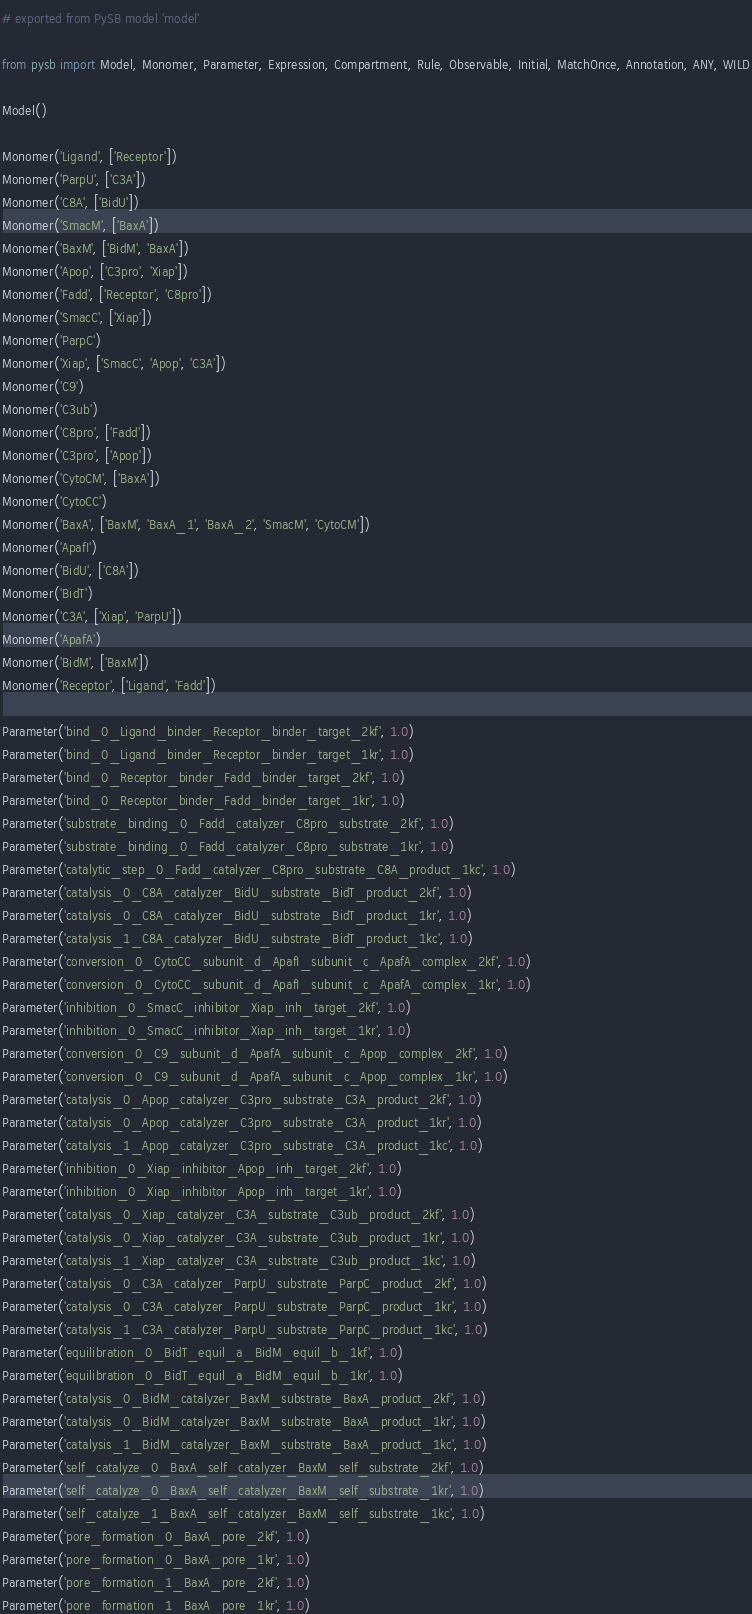Convert code to text. <code><loc_0><loc_0><loc_500><loc_500><_Python_># exported from PySB model 'model'

from pysb import Model, Monomer, Parameter, Expression, Compartment, Rule, Observable, Initial, MatchOnce, Annotation, ANY, WILD

Model()

Monomer('Ligand', ['Receptor'])
Monomer('ParpU', ['C3A'])
Monomer('C8A', ['BidU'])
Monomer('SmacM', ['BaxA'])
Monomer('BaxM', ['BidM', 'BaxA'])
Monomer('Apop', ['C3pro', 'Xiap'])
Monomer('Fadd', ['Receptor', 'C8pro'])
Monomer('SmacC', ['Xiap'])
Monomer('ParpC')
Monomer('Xiap', ['SmacC', 'Apop', 'C3A'])
Monomer('C9')
Monomer('C3ub')
Monomer('C8pro', ['Fadd'])
Monomer('C3pro', ['Apop'])
Monomer('CytoCM', ['BaxA'])
Monomer('CytoCC')
Monomer('BaxA', ['BaxM', 'BaxA_1', 'BaxA_2', 'SmacM', 'CytoCM'])
Monomer('ApafI')
Monomer('BidU', ['C8A'])
Monomer('BidT')
Monomer('C3A', ['Xiap', 'ParpU'])
Monomer('ApafA')
Monomer('BidM', ['BaxM'])
Monomer('Receptor', ['Ligand', 'Fadd'])

Parameter('bind_0_Ligand_binder_Receptor_binder_target_2kf', 1.0)
Parameter('bind_0_Ligand_binder_Receptor_binder_target_1kr', 1.0)
Parameter('bind_0_Receptor_binder_Fadd_binder_target_2kf', 1.0)
Parameter('bind_0_Receptor_binder_Fadd_binder_target_1kr', 1.0)
Parameter('substrate_binding_0_Fadd_catalyzer_C8pro_substrate_2kf', 1.0)
Parameter('substrate_binding_0_Fadd_catalyzer_C8pro_substrate_1kr', 1.0)
Parameter('catalytic_step_0_Fadd_catalyzer_C8pro_substrate_C8A_product_1kc', 1.0)
Parameter('catalysis_0_C8A_catalyzer_BidU_substrate_BidT_product_2kf', 1.0)
Parameter('catalysis_0_C8A_catalyzer_BidU_substrate_BidT_product_1kr', 1.0)
Parameter('catalysis_1_C8A_catalyzer_BidU_substrate_BidT_product_1kc', 1.0)
Parameter('conversion_0_CytoCC_subunit_d_ApafI_subunit_c_ApafA_complex_2kf', 1.0)
Parameter('conversion_0_CytoCC_subunit_d_ApafI_subunit_c_ApafA_complex_1kr', 1.0)
Parameter('inhibition_0_SmacC_inhibitor_Xiap_inh_target_2kf', 1.0)
Parameter('inhibition_0_SmacC_inhibitor_Xiap_inh_target_1kr', 1.0)
Parameter('conversion_0_C9_subunit_d_ApafA_subunit_c_Apop_complex_2kf', 1.0)
Parameter('conversion_0_C9_subunit_d_ApafA_subunit_c_Apop_complex_1kr', 1.0)
Parameter('catalysis_0_Apop_catalyzer_C3pro_substrate_C3A_product_2kf', 1.0)
Parameter('catalysis_0_Apop_catalyzer_C3pro_substrate_C3A_product_1kr', 1.0)
Parameter('catalysis_1_Apop_catalyzer_C3pro_substrate_C3A_product_1kc', 1.0)
Parameter('inhibition_0_Xiap_inhibitor_Apop_inh_target_2kf', 1.0)
Parameter('inhibition_0_Xiap_inhibitor_Apop_inh_target_1kr', 1.0)
Parameter('catalysis_0_Xiap_catalyzer_C3A_substrate_C3ub_product_2kf', 1.0)
Parameter('catalysis_0_Xiap_catalyzer_C3A_substrate_C3ub_product_1kr', 1.0)
Parameter('catalysis_1_Xiap_catalyzer_C3A_substrate_C3ub_product_1kc', 1.0)
Parameter('catalysis_0_C3A_catalyzer_ParpU_substrate_ParpC_product_2kf', 1.0)
Parameter('catalysis_0_C3A_catalyzer_ParpU_substrate_ParpC_product_1kr', 1.0)
Parameter('catalysis_1_C3A_catalyzer_ParpU_substrate_ParpC_product_1kc', 1.0)
Parameter('equilibration_0_BidT_equil_a_BidM_equil_b_1kf', 1.0)
Parameter('equilibration_0_BidT_equil_a_BidM_equil_b_1kr', 1.0)
Parameter('catalysis_0_BidM_catalyzer_BaxM_substrate_BaxA_product_2kf', 1.0)
Parameter('catalysis_0_BidM_catalyzer_BaxM_substrate_BaxA_product_1kr', 1.0)
Parameter('catalysis_1_BidM_catalyzer_BaxM_substrate_BaxA_product_1kc', 1.0)
Parameter('self_catalyze_0_BaxA_self_catalyzer_BaxM_self_substrate_2kf', 1.0)
Parameter('self_catalyze_0_BaxA_self_catalyzer_BaxM_self_substrate_1kr', 1.0)
Parameter('self_catalyze_1_BaxA_self_catalyzer_BaxM_self_substrate_1kc', 1.0)
Parameter('pore_formation_0_BaxA_pore_2kf', 1.0)
Parameter('pore_formation_0_BaxA_pore_1kr', 1.0)
Parameter('pore_formation_1_BaxA_pore_2kf', 1.0)
Parameter('pore_formation_1_BaxA_pore_1kr', 1.0)</code> 